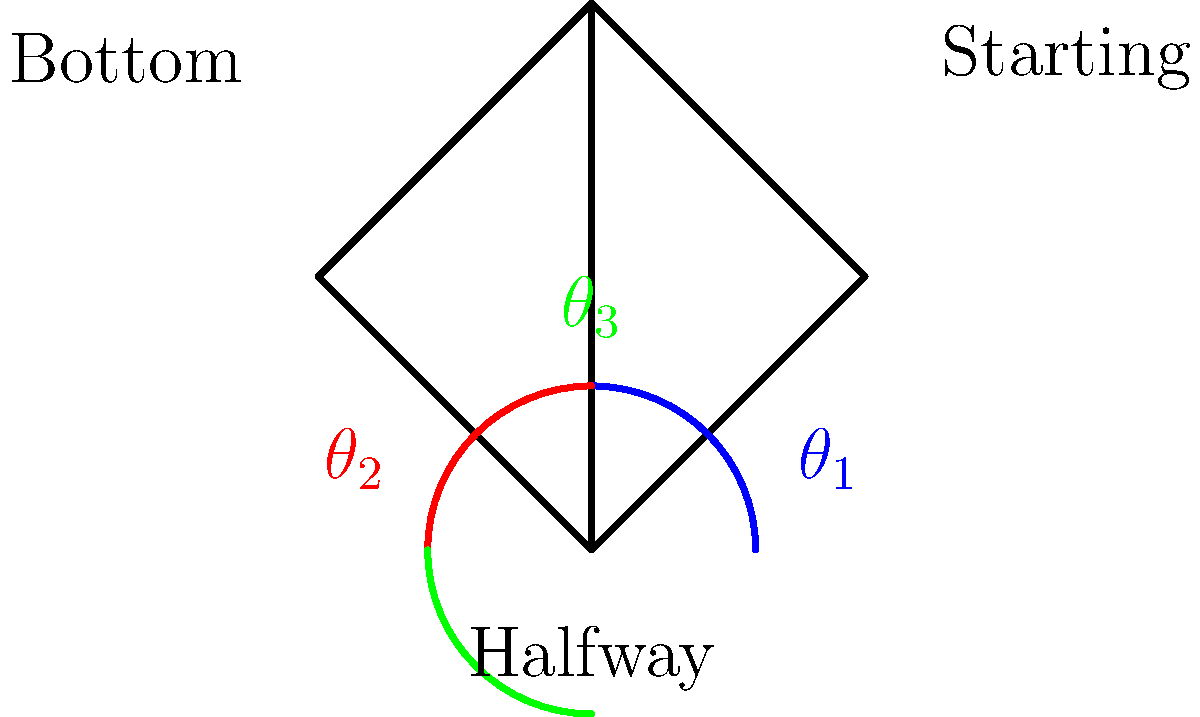In a squat exercise, the joint angles change throughout the movement. Considering the hip joint, which angle ($\theta_1$, $\theta_2$, or $\theta_3$) represents the smallest hip flexion angle, and at which phase of the squat does it occur? To answer this question, let's analyze the squat movement and the hip joint angles:

1. The squat exercise typically consists of three main phases: starting position (standing), bottom position (deepest part of the squat), and halfway position (midpoint between starting and bottom).

2. Hip flexion angle is the angle between the trunk and the thigh. A smaller angle indicates less flexion (closer to standing position), while a larger angle indicates more flexion (closer to sitting position).

3. In the diagram:
   - $\theta_1$ (blue) represents the starting position
   - $\theta_2$ (red) represents the bottom position
   - $\theta_3$ (green) represents the halfway position

4. At the starting position, the hip is in its most extended state, with the trunk and thigh nearly aligned vertically. This results in the smallest hip flexion angle.

5. As the squat progresses to the halfway and then to the bottom position, the hip flexion angle increases.

6. Therefore, $\theta_1$ represents the smallest hip flexion angle, occurring at the starting phase of the squat.
Answer: $\theta_1$, starting position 